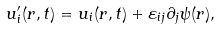Convert formula to latex. <formula><loc_0><loc_0><loc_500><loc_500>u _ { i } ^ { \prime } ( { r } , t ) = u _ { i } ( { r } , t ) + \varepsilon _ { i j } \partial _ { j } \psi ( { r } ) ,</formula> 